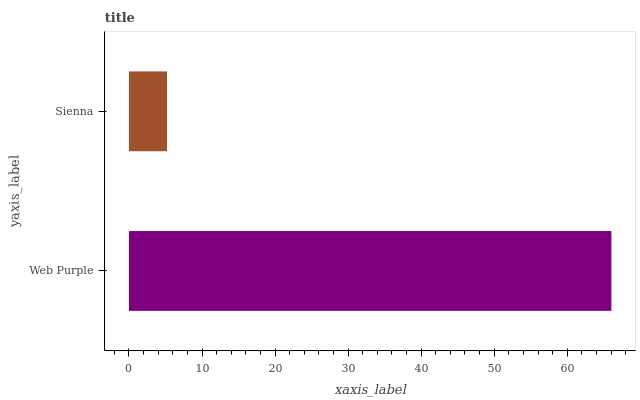Is Sienna the minimum?
Answer yes or no. Yes. Is Web Purple the maximum?
Answer yes or no. Yes. Is Sienna the maximum?
Answer yes or no. No. Is Web Purple greater than Sienna?
Answer yes or no. Yes. Is Sienna less than Web Purple?
Answer yes or no. Yes. Is Sienna greater than Web Purple?
Answer yes or no. No. Is Web Purple less than Sienna?
Answer yes or no. No. Is Web Purple the high median?
Answer yes or no. Yes. Is Sienna the low median?
Answer yes or no. Yes. Is Sienna the high median?
Answer yes or no. No. Is Web Purple the low median?
Answer yes or no. No. 